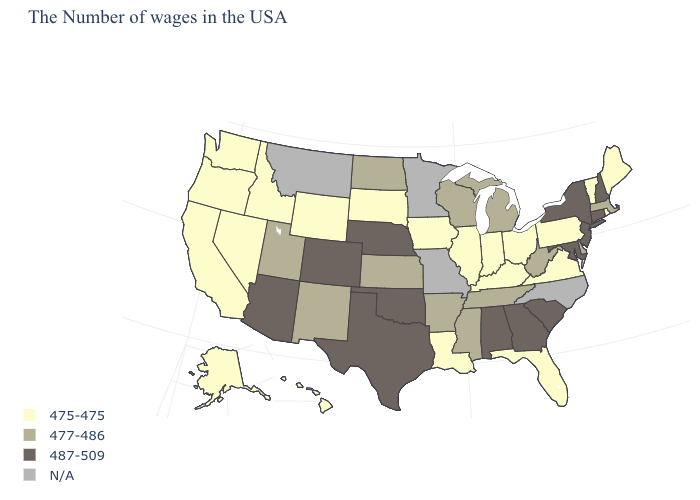Name the states that have a value in the range 487-509?
Keep it brief. New Hampshire, Connecticut, New York, New Jersey, Maryland, South Carolina, Georgia, Alabama, Nebraska, Oklahoma, Texas, Colorado, Arizona. Among the states that border Ohio , which have the highest value?
Give a very brief answer. West Virginia, Michigan. Name the states that have a value in the range 477-486?
Short answer required. Massachusetts, Delaware, West Virginia, Michigan, Tennessee, Wisconsin, Mississippi, Arkansas, Kansas, North Dakota, New Mexico, Utah. Name the states that have a value in the range 475-475?
Short answer required. Maine, Rhode Island, Vermont, Pennsylvania, Virginia, Ohio, Florida, Kentucky, Indiana, Illinois, Louisiana, Iowa, South Dakota, Wyoming, Idaho, Nevada, California, Washington, Oregon, Alaska, Hawaii. What is the value of Washington?
Short answer required. 475-475. What is the highest value in the MidWest ?
Answer briefly. 487-509. Does Alabama have the highest value in the South?
Quick response, please. Yes. Name the states that have a value in the range N/A?
Write a very short answer. North Carolina, Missouri, Minnesota, Montana. Does the first symbol in the legend represent the smallest category?
Short answer required. Yes. Which states have the lowest value in the West?
Give a very brief answer. Wyoming, Idaho, Nevada, California, Washington, Oregon, Alaska, Hawaii. Which states hav the highest value in the West?
Write a very short answer. Colorado, Arizona. What is the value of Mississippi?
Concise answer only. 477-486. Name the states that have a value in the range 477-486?
Answer briefly. Massachusetts, Delaware, West Virginia, Michigan, Tennessee, Wisconsin, Mississippi, Arkansas, Kansas, North Dakota, New Mexico, Utah. Does Virginia have the lowest value in the South?
Concise answer only. Yes. Does the first symbol in the legend represent the smallest category?
Concise answer only. Yes. 